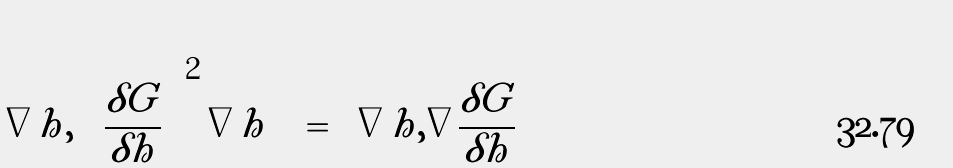Convert formula to latex. <formula><loc_0><loc_0><loc_500><loc_500>\left \langle \nabla h , \left ( \frac { \delta G } { \delta h } \right ) ^ { 2 } \nabla h \right \rangle = \left \langle \nabla h , \nabla \frac { \delta G } { \delta h } \right \rangle</formula> 